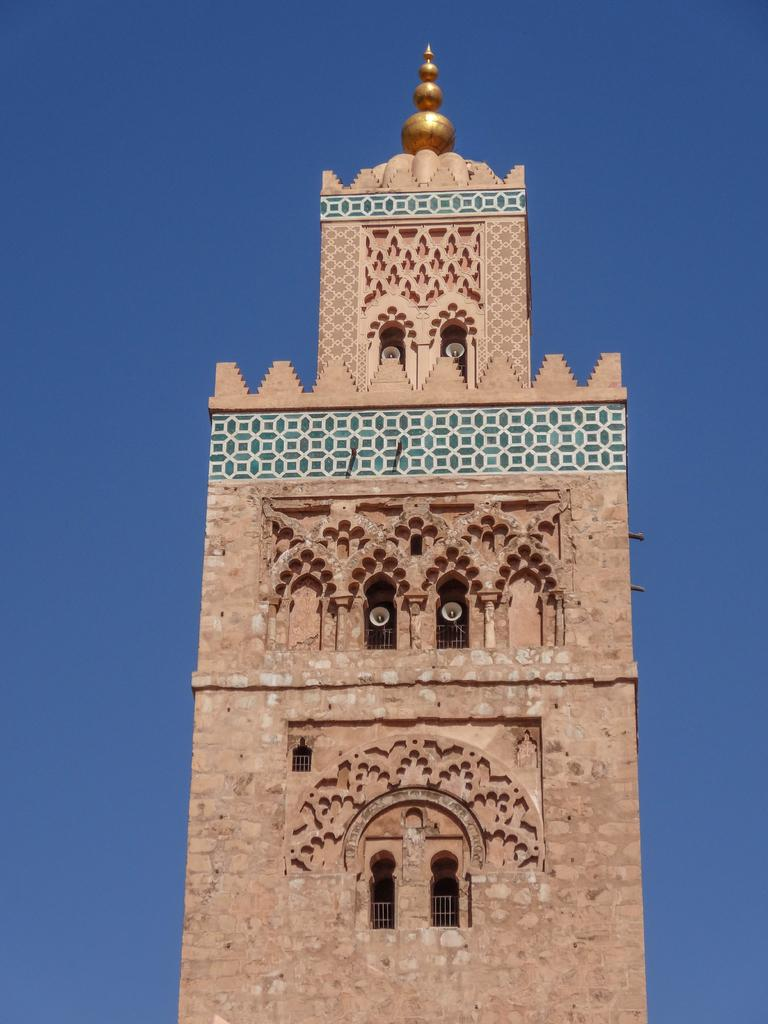What is the main subject of the image? There is a monument in the image. What colors can be seen on the monument? The monument has brown, white, and green colors. Is there any other notable feature on the monument? Yes, there is a golden color thing on the monument. What is visible in the background of the image? The sky is blue in the background of the image. What type of lock is used to secure the skirt on the monument in the image? There is no lock or skirt present on the monument in the image. What kind of music can be heard coming from the monument in the image? There is no music or indication of sound in the image; it only features a monument with specific colors and a golden feature. 